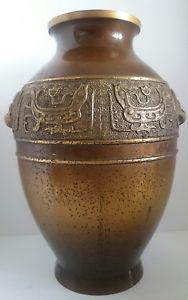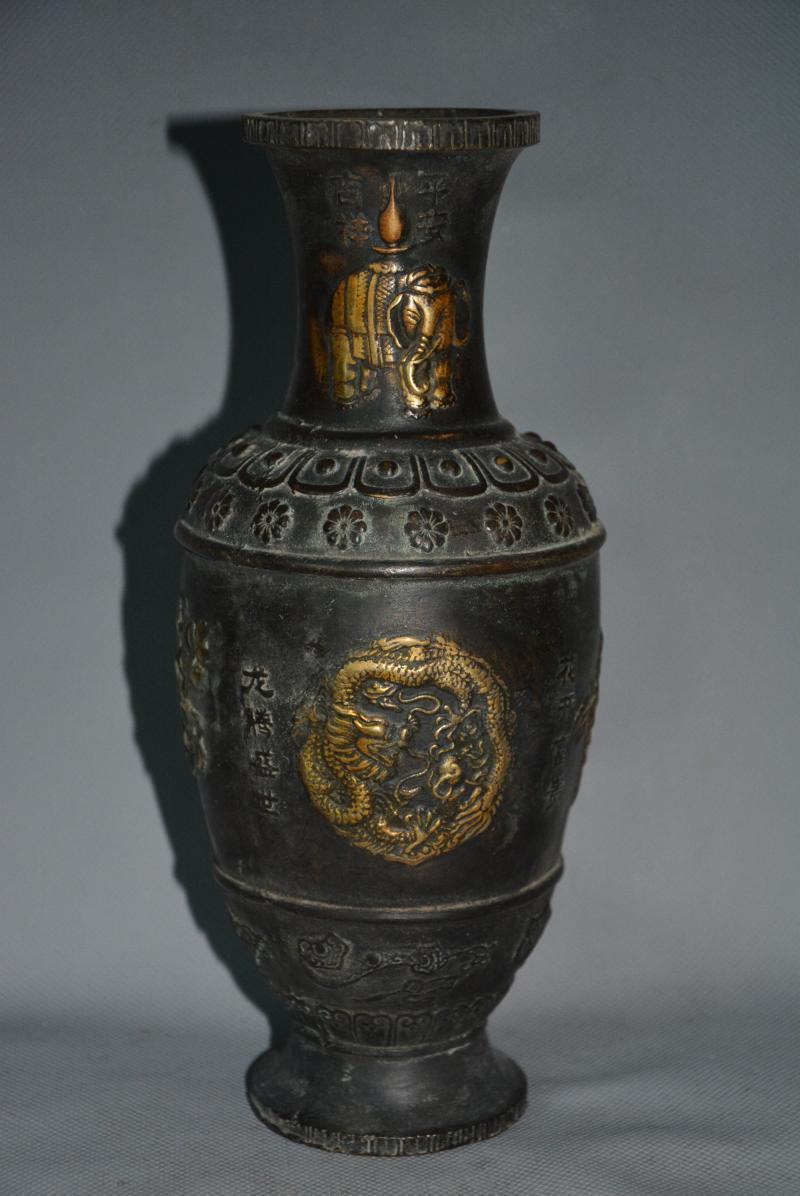The first image is the image on the left, the second image is the image on the right. Given the left and right images, does the statement "There are side handles on the vase." hold true? Answer yes or no. No. 